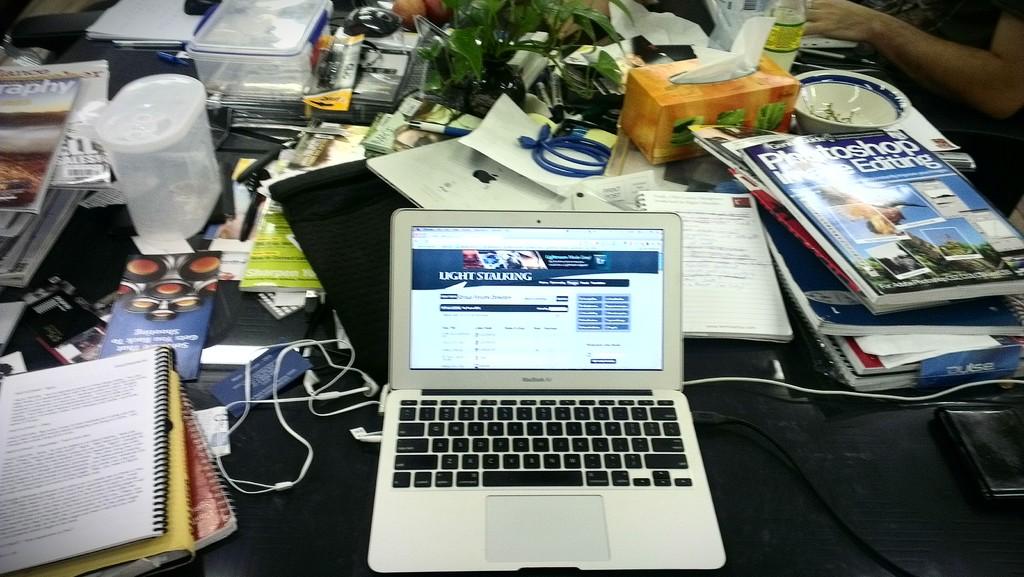What is one of the textbooks shown about?
Give a very brief answer. Photoshop editing. What is the large-font header on the website on the laptop?
Give a very brief answer. Light stalking. 